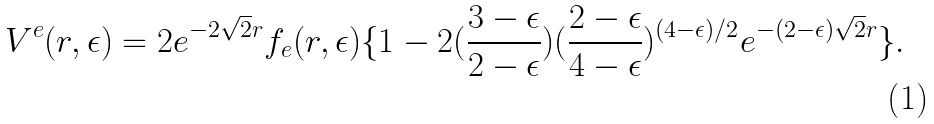<formula> <loc_0><loc_0><loc_500><loc_500>V ^ { e } ( r , \epsilon ) = 2 e ^ { - 2 \sqrt { 2 } r } f _ { e } ( r , \epsilon ) \{ 1 - 2 ( { \frac { 3 - \epsilon } { 2 - \epsilon } } ) ( { \frac { 2 - \epsilon } { 4 - \epsilon } } ) ^ { ( 4 - \epsilon ) / 2 } e ^ { - ( 2 - \epsilon ) \sqrt { 2 } r } \} .</formula> 